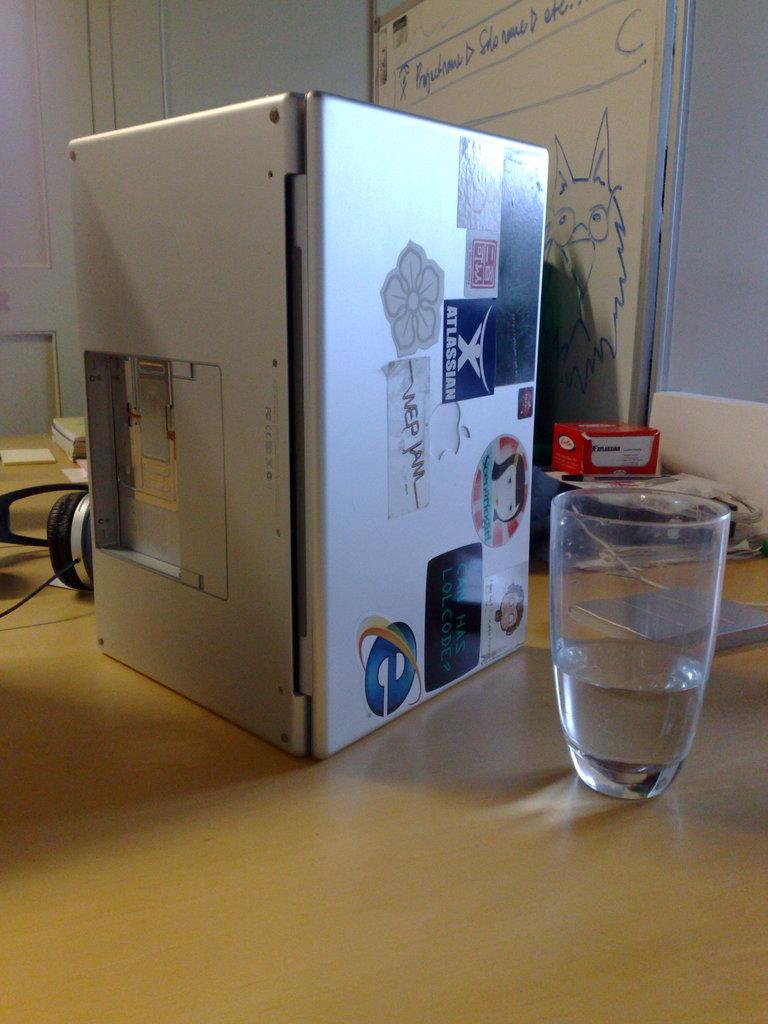What browser logo is in the box?
Your response must be concise. Internet explorer. 